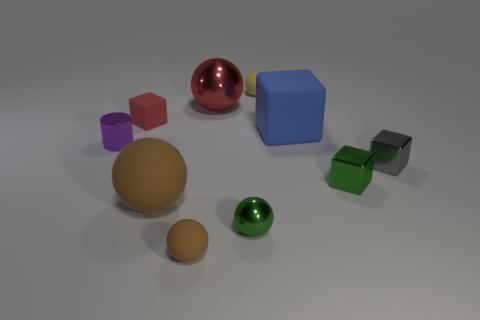Is there anything else that has the same shape as the purple shiny object?
Provide a short and direct response. No. Do the large matte block and the metal cylinder have the same color?
Provide a short and direct response. No. There is another matte sphere that is the same size as the red sphere; what is its color?
Your response must be concise. Brown. Is the size of the brown thing in front of the small green sphere the same as the matte cube right of the small yellow rubber thing?
Provide a succinct answer. No. What is the size of the rubber sphere right of the tiny rubber thing that is in front of the tiny purple metallic thing in front of the red matte block?
Provide a succinct answer. Small. What shape is the small metal thing that is left of the tiny block behind the tiny gray metallic thing?
Your response must be concise. Cylinder. Is the color of the matte cube to the right of the small red cube the same as the big shiny thing?
Keep it short and to the point. No. There is a sphere that is both on the right side of the big red ball and in front of the tiny yellow matte sphere; what color is it?
Offer a terse response. Green. Is there a yellow thing made of the same material as the yellow ball?
Your answer should be compact. No. What is the size of the red rubber object?
Your answer should be very brief. Small. 